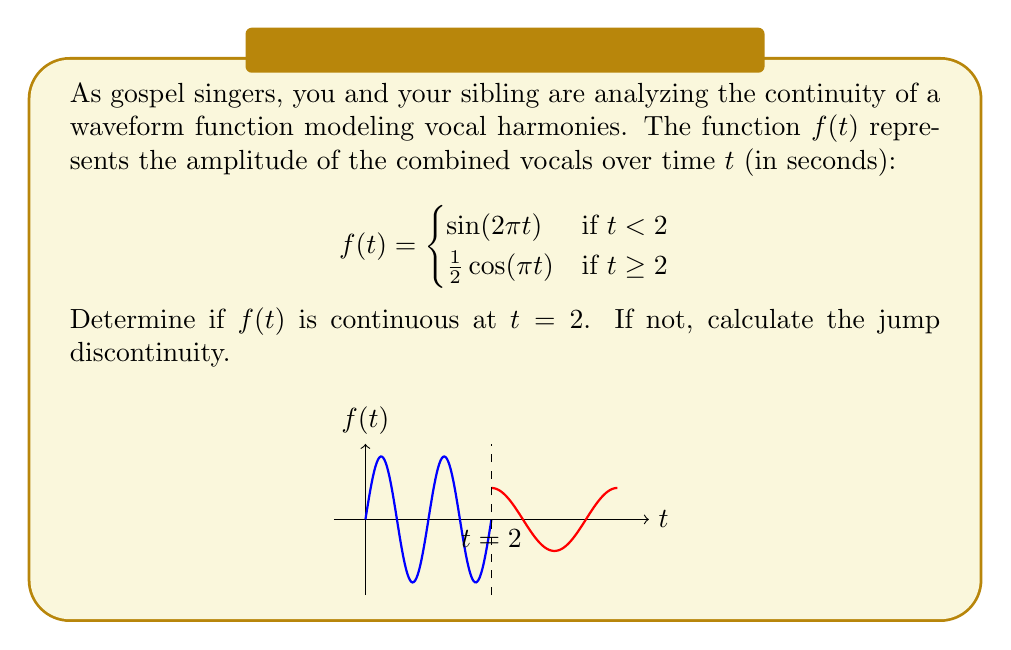Give your solution to this math problem. To determine if $f(t)$ is continuous at $t = 2$, we need to check three conditions:

1. $f(2)$ exists
2. $\lim_{t \to 2^-} f(t)$ exists
3. $\lim_{t \to 2^-} f(t) = f(2) = \lim_{t \to 2^+} f(t)$

Step 1: Check if $f(2)$ exists
$f(2) = \frac{1}{2}\cos(\pi \cdot 2) = \frac{1}{2}\cos(2\pi) = \frac{1}{2}$

Step 2: Calculate $\lim_{t \to 2^-} f(t)$
$\lim_{t \to 2^-} f(t) = \lim_{t \to 2^-} \sin(2\pi t) = \sin(2\pi \cdot 2) = \sin(4\pi) = 0$

Step 3: Calculate $\lim_{t \to 2^+} f(t)$
$\lim_{t \to 2^+} f(t) = \lim_{t \to 2^+} \frac{1}{2}\cos(\pi t) = \frac{1}{2}\cos(\pi \cdot 2) = \frac{1}{2}$

Since $\lim_{t \to 2^-} f(t) \neq \lim_{t \to 2^+} f(t)$, $f(t)$ is not continuous at $t = 2$.

The jump discontinuity is the difference between the right-hand and left-hand limits:
$\lim_{t \to 2^+} f(t) - \lim_{t \to 2^-} f(t) = \frac{1}{2} - 0 = \frac{1}{2}$
Answer: Not continuous; jump discontinuity = $\frac{1}{2}$ 